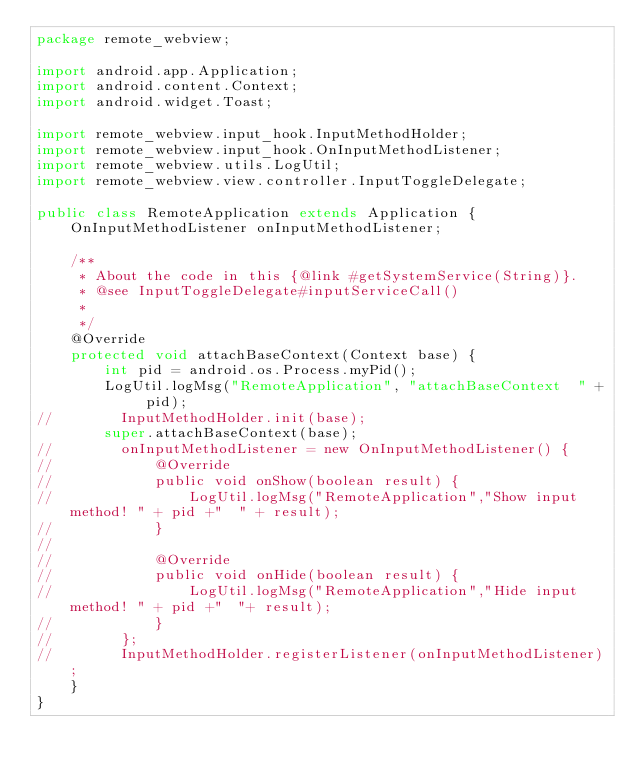<code> <loc_0><loc_0><loc_500><loc_500><_Java_>package remote_webview;

import android.app.Application;
import android.content.Context;
import android.widget.Toast;

import remote_webview.input_hook.InputMethodHolder;
import remote_webview.input_hook.OnInputMethodListener;
import remote_webview.utils.LogUtil;
import remote_webview.view.controller.InputToggleDelegate;

public class RemoteApplication extends Application {
    OnInputMethodListener onInputMethodListener;

    /**
     * About the code in this {@link #getSystemService(String)}.
     * @see InputToggleDelegate#inputServiceCall() 
     *
     */
    @Override
    protected void attachBaseContext(Context base) {
        int pid = android.os.Process.myPid();
        LogUtil.logMsg("RemoteApplication", "attachBaseContext  " + pid);
//        InputMethodHolder.init(base);
        super.attachBaseContext(base);
//        onInputMethodListener = new OnInputMethodListener() {
//            @Override
//            public void onShow(boolean result) {
//                LogUtil.logMsg("RemoteApplication","Show input method! " + pid +"  " + result);
//            }
//
//            @Override
//            public void onHide(boolean result) {
//                LogUtil.logMsg("RemoteApplication","Hide input method! " + pid +"  "+ result);
//            }
//        };
//        InputMethodHolder.registerListener(onInputMethodListener);
    }
}
</code> 